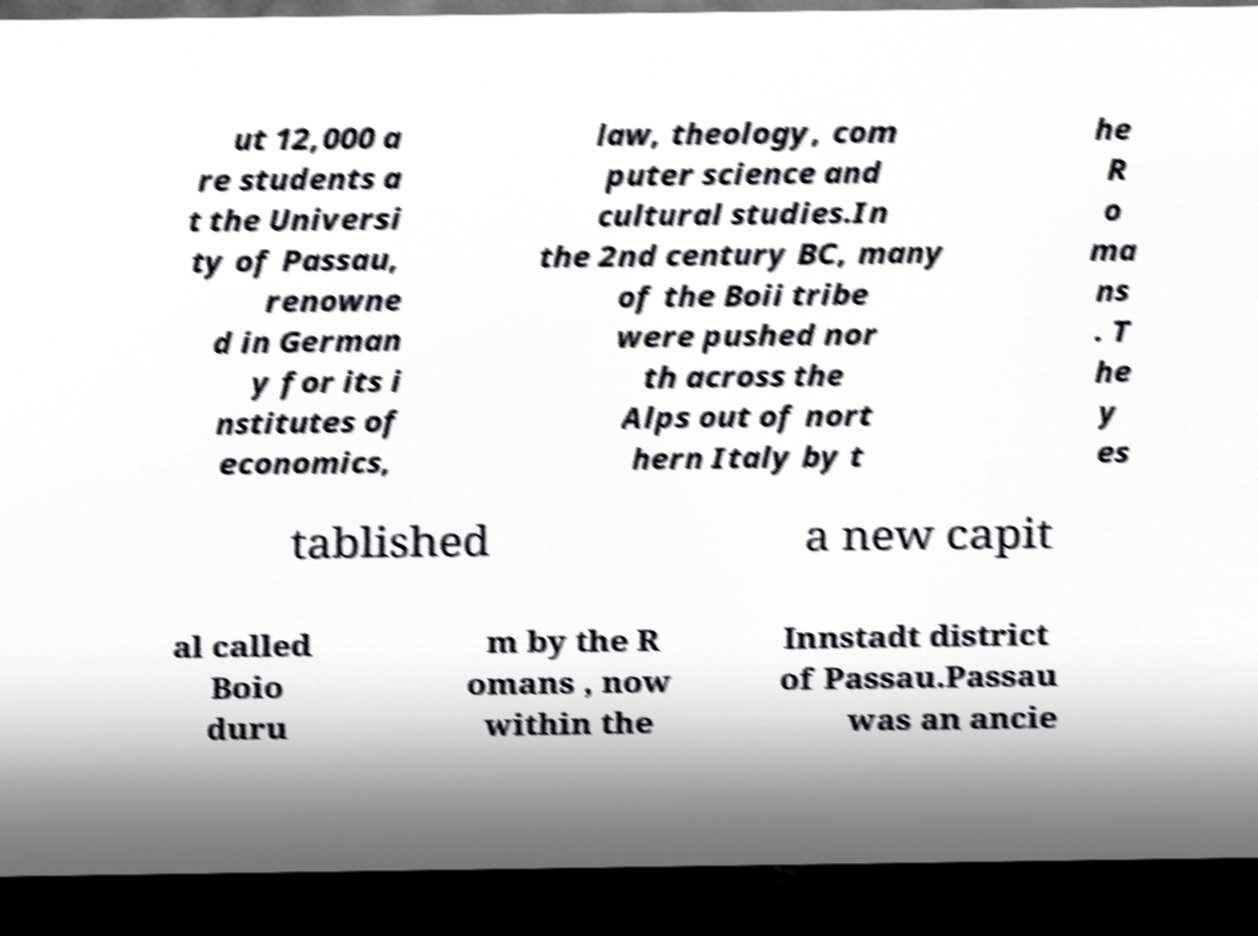I need the written content from this picture converted into text. Can you do that? ut 12,000 a re students a t the Universi ty of Passau, renowne d in German y for its i nstitutes of economics, law, theology, com puter science and cultural studies.In the 2nd century BC, many of the Boii tribe were pushed nor th across the Alps out of nort hern Italy by t he R o ma ns . T he y es tablished a new capit al called Boio duru m by the R omans , now within the Innstadt district of Passau.Passau was an ancie 